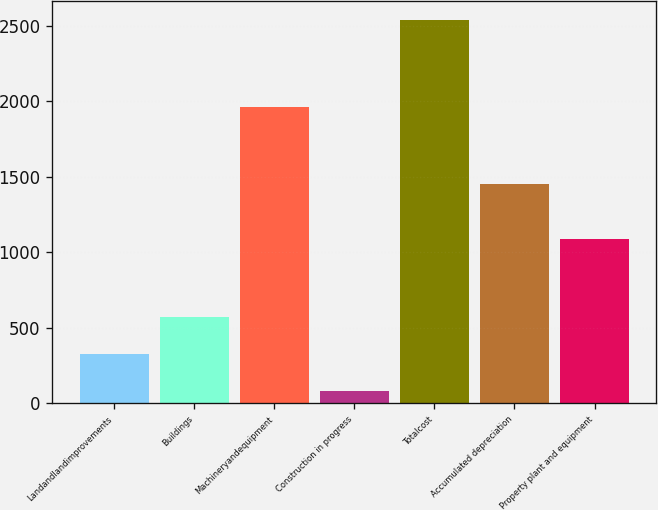<chart> <loc_0><loc_0><loc_500><loc_500><bar_chart><fcel>Landandlandimprovements<fcel>Buildings<fcel>Machineryandequipment<fcel>Construction in progress<fcel>Totalcost<fcel>Accumulated depreciation<fcel>Property plant and equipment<nl><fcel>323.21<fcel>569.32<fcel>1965.7<fcel>77.1<fcel>2538.2<fcel>1450.4<fcel>1087.8<nl></chart> 